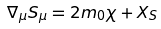Convert formula to latex. <formula><loc_0><loc_0><loc_500><loc_500>\nabla _ { \mu } S _ { \mu } = 2 m _ { 0 } \chi + X _ { S }</formula> 